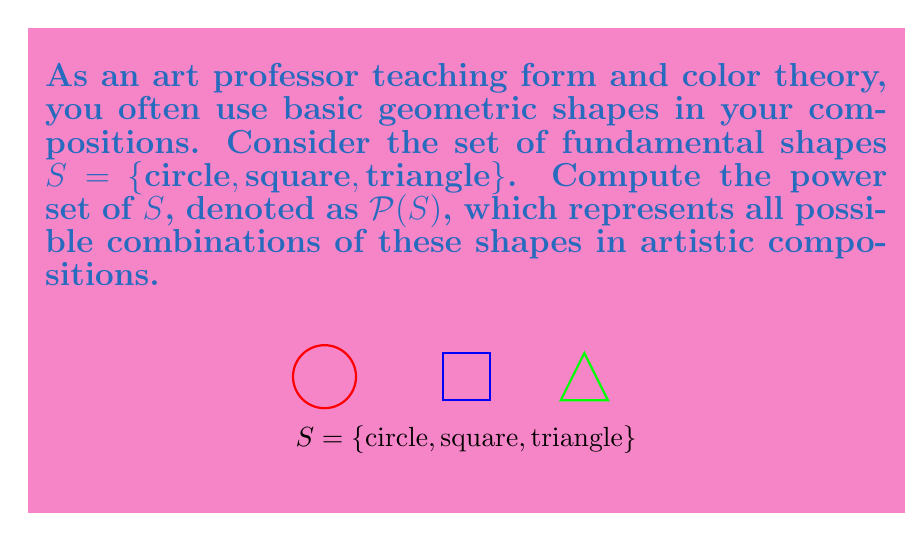Can you answer this question? To compute the power set of $S$, we need to list all possible subsets of $S$, including the empty set and $S$ itself. Let's approach this step-by-step:

1) First, recall that for a set with $n$ elements, its power set will have $2^n$ elements.

2) In this case, $|S| = 3$, so $|\mathcal{P}(S)| = 2^3 = 8$.

3) Now, let's list all possible subsets:

   - The empty set: $\{\}$
   - Single element subsets: $\{\text{circle}\}$, $\{\text{square}\}$, $\{\text{triangle}\}$
   - Two element subsets: $\{\text{circle}, \text{square}\}$, $\{\text{circle}, \text{triangle}\}$, $\{\text{square}, \text{triangle}\}$
   - The full set: $\{\text{circle}, \text{square}, \text{triangle}\}$

4) Therefore, the power set $\mathcal{P}(S)$ is the set of all these subsets.

5) In set notation, we can write this as:

   $$\mathcal{P}(S) = \{\{\}, \{\text{circle}\}, \{\text{square}\}, \{\text{triangle}\}, \{\text{circle}, \text{square}\}, \{\text{circle}, \text{triangle}\}, \{\text{square}, \text{triangle}\}, \{\text{circle}, \text{square}, \text{triangle}\}\}$$

This power set represents all possible combinations of basic shapes that could be used in an artistic composition, from using no shapes (empty canvas) to using all three shapes together.
Answer: $$\mathcal{P}(S) = \{\{\}, \{\text{circle}\}, \{\text{square}\}, \{\text{triangle}\}, \{\text{circle}, \text{square}\}, \{\text{circle}, \text{triangle}\}, \{\text{square}, \text{triangle}\}, \{\text{circle}, \text{square}, \text{triangle}\}\}$$ 